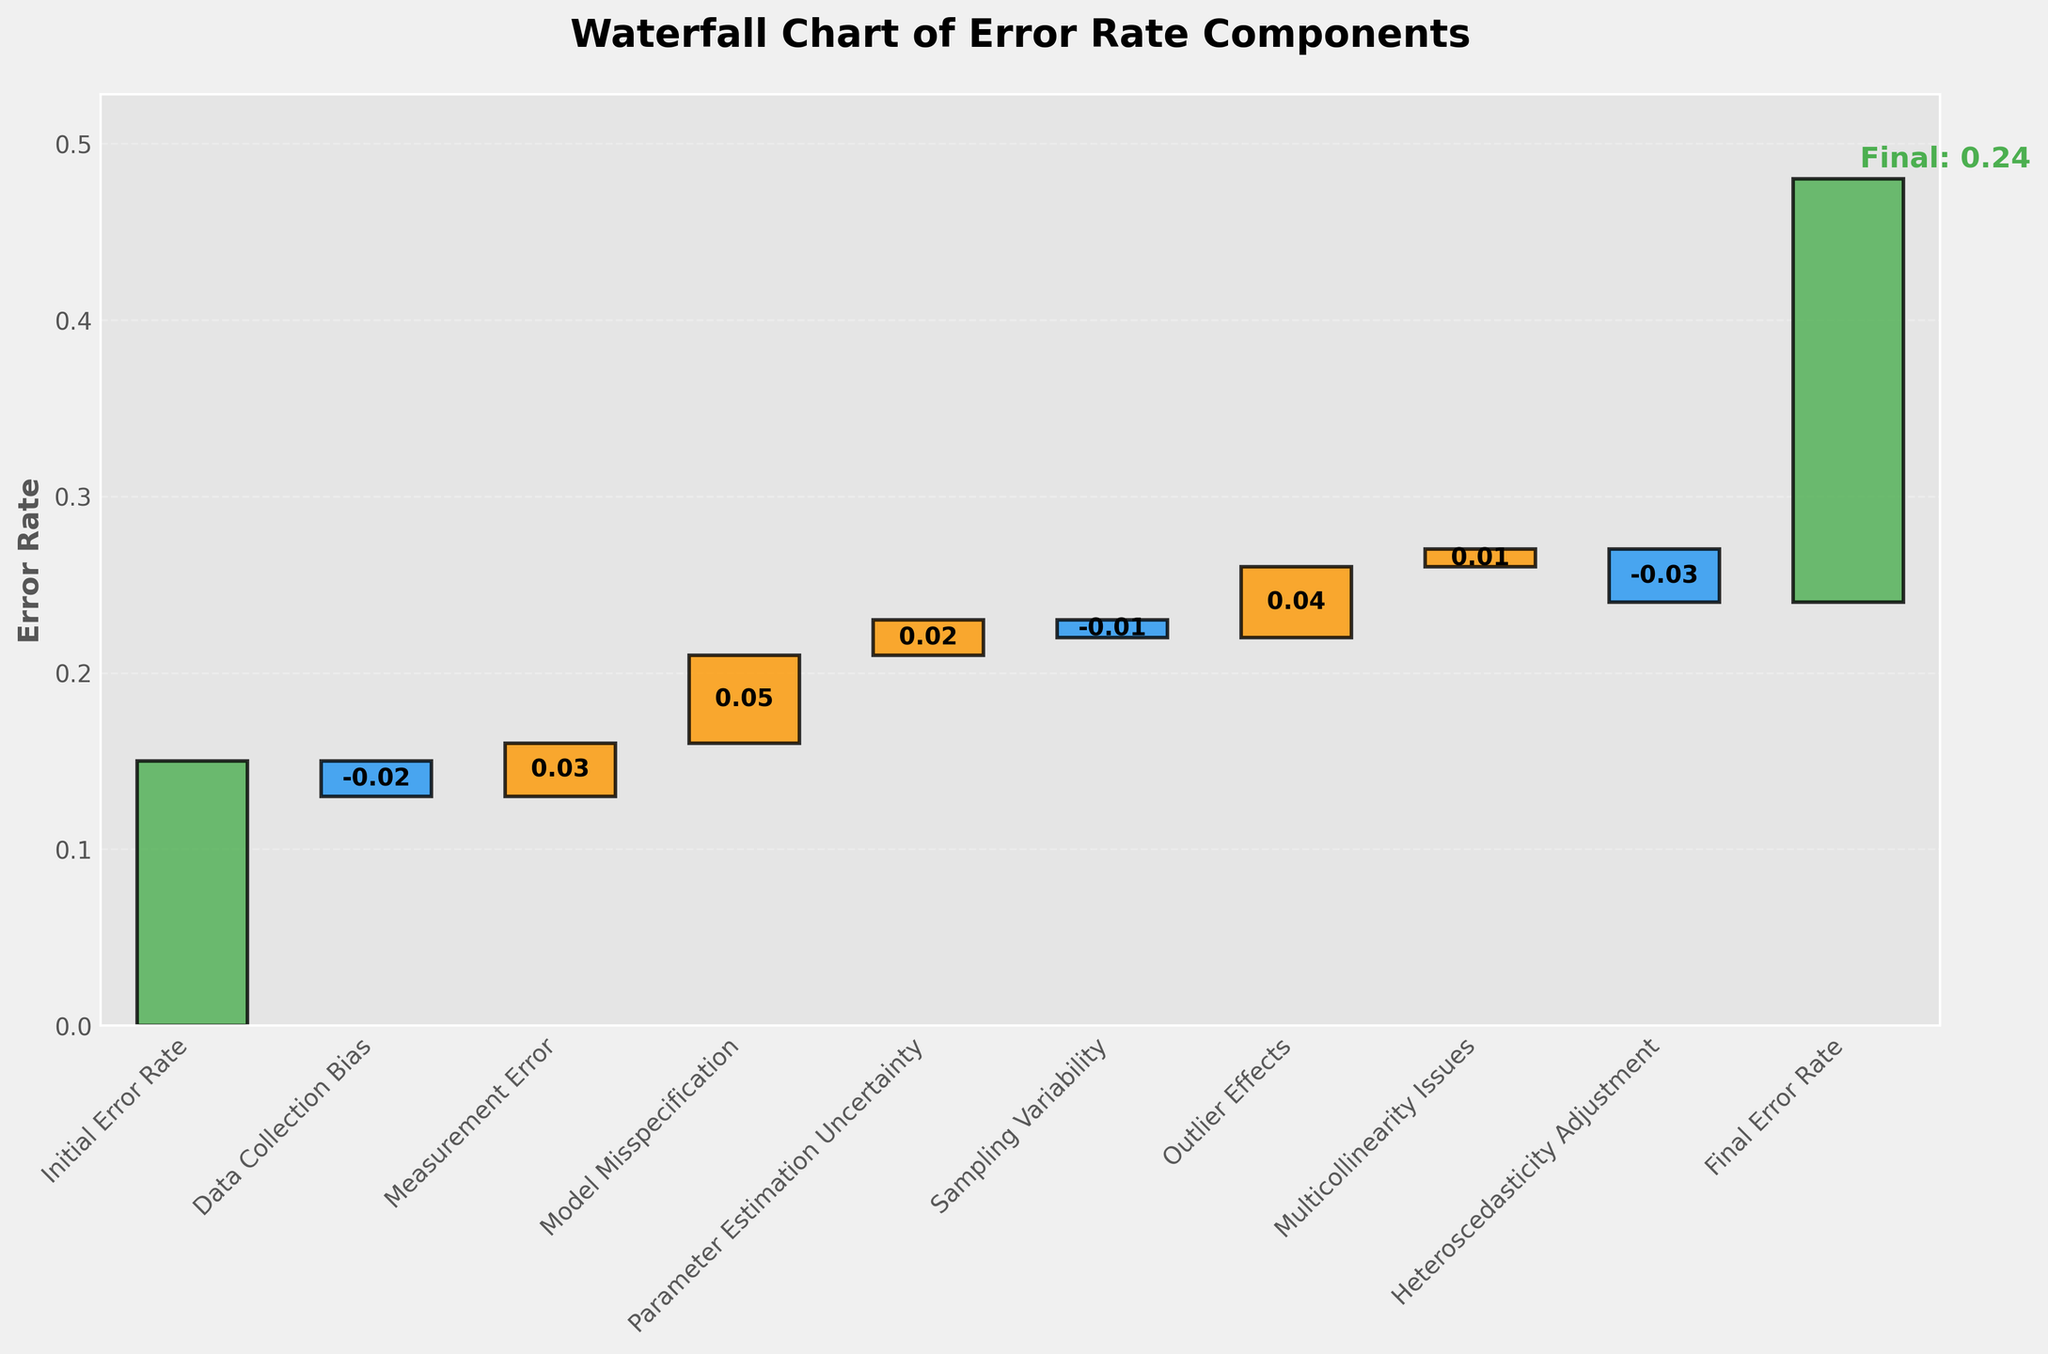What is the title of the figure? The title of the figure is displayed at the top and usually summarizes the content or purpose of the plot. In this case, the title is "Waterfall Chart of Error Rate Components".
Answer: Waterfall Chart of Error Rate Components What is the initial error rate? The initial error rate is the first value in the waterfall chart, which is indicated at the leftmost bar. It is labeled as "Initial Error Rate" with a value of 0.15.
Answer: 0.15 How many sources of uncertainty are accounted for in the chart? To determine the number of sources of uncertainty, count the bars between the initial and final error rate bars. These bars represent different sources. There are 7 sources of uncertainty: Data Collection Bias, Measurement Error, Model Misspecification, Parameter Estimation Uncertainty, Sampling Variability, Outlier Effects, and Multicollinearity Issues, and Heteroscedasticity Adjustment.
Answer: 7 What is the combined effect of Data Collection Bias and Measurement Error on the error rate? First, identify the values for Data Collection Bias (-0.02) and Measurement Error (0.03). Then, sum these two values: -0.02 + 0.03 = 0.01.
Answer: 0.01 What is the largest positive contributor to the error rate? Identify the bar with the highest positive value. In this case, Model Misspecification has the largest positive contribution of 0.05.
Answer: Model Misspecification Which source has a negative impact on the error rate? Identify all bars with negative values. The sources with negative impacts are Data Collection Bias (-0.02), Sampling Variability (-0.01), and Heteroscedasticity Adjustment (-0.03).
Answer: Data Collection Bias, Sampling Variability, Heteroscedasticity Adjustment What is the final error rate? The final error rate is the value at the rightmost bar, labeled as "Final Error Rate" with a value of 0.24.
Answer: 0.24 Which has a greater absolute impact on the error rate, Outlier Effects or Multicollinearity Issues? Compare the absolute values of Outlier Effects (0.04) and Multicollinearity Issues (0.01). Outlier Effects have a greater absolute impact because 0.04 > 0.01.
Answer: Outlier Effects Did Sampling Variability increase or decrease the error rate? Sampling Variability has a value of -0.01. Negative values indicate a decrease. Thus, Sampling Variability decreased the error rate.
Answer: Decrease What is the cumulative effect of all sources of uncertainty on the error rate? To find the cumulative effect, sum all the values except the initial value. The sum of the changes is -0.02 + 0.03 + 0.05 + 0.02 - 0.01 + 0.04 + 0.01 - 0.03 = 0.09.
Answer: 0.09 